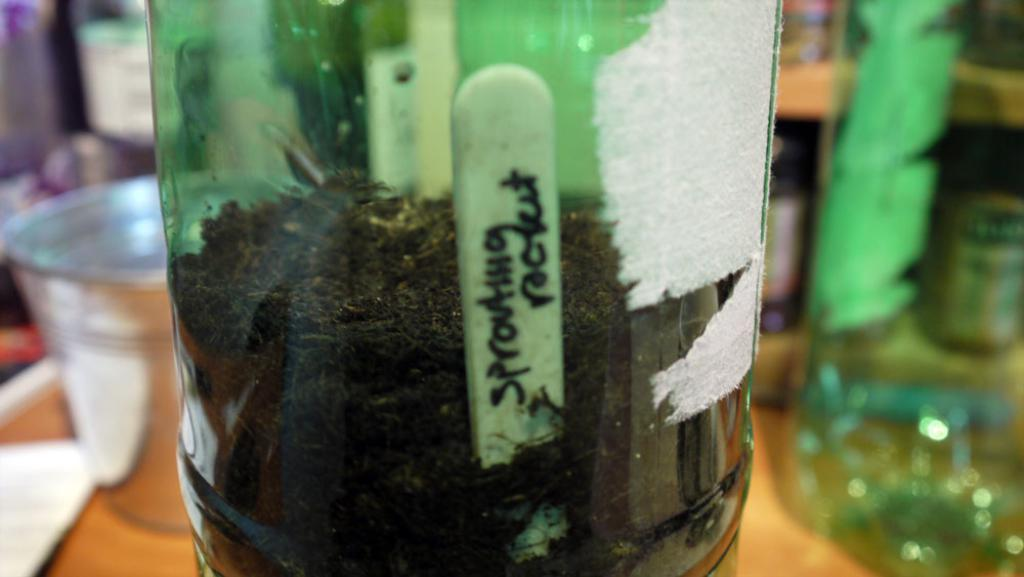What object can be seen in the image? There is a bottle in the image. What is inside the bottle? There is a wooden stick in the bottle. What birthday celebration is taking place in the alley in the image? There is no birthday celebration or alley present in the image; it only features a bottle with a wooden stick inside. 